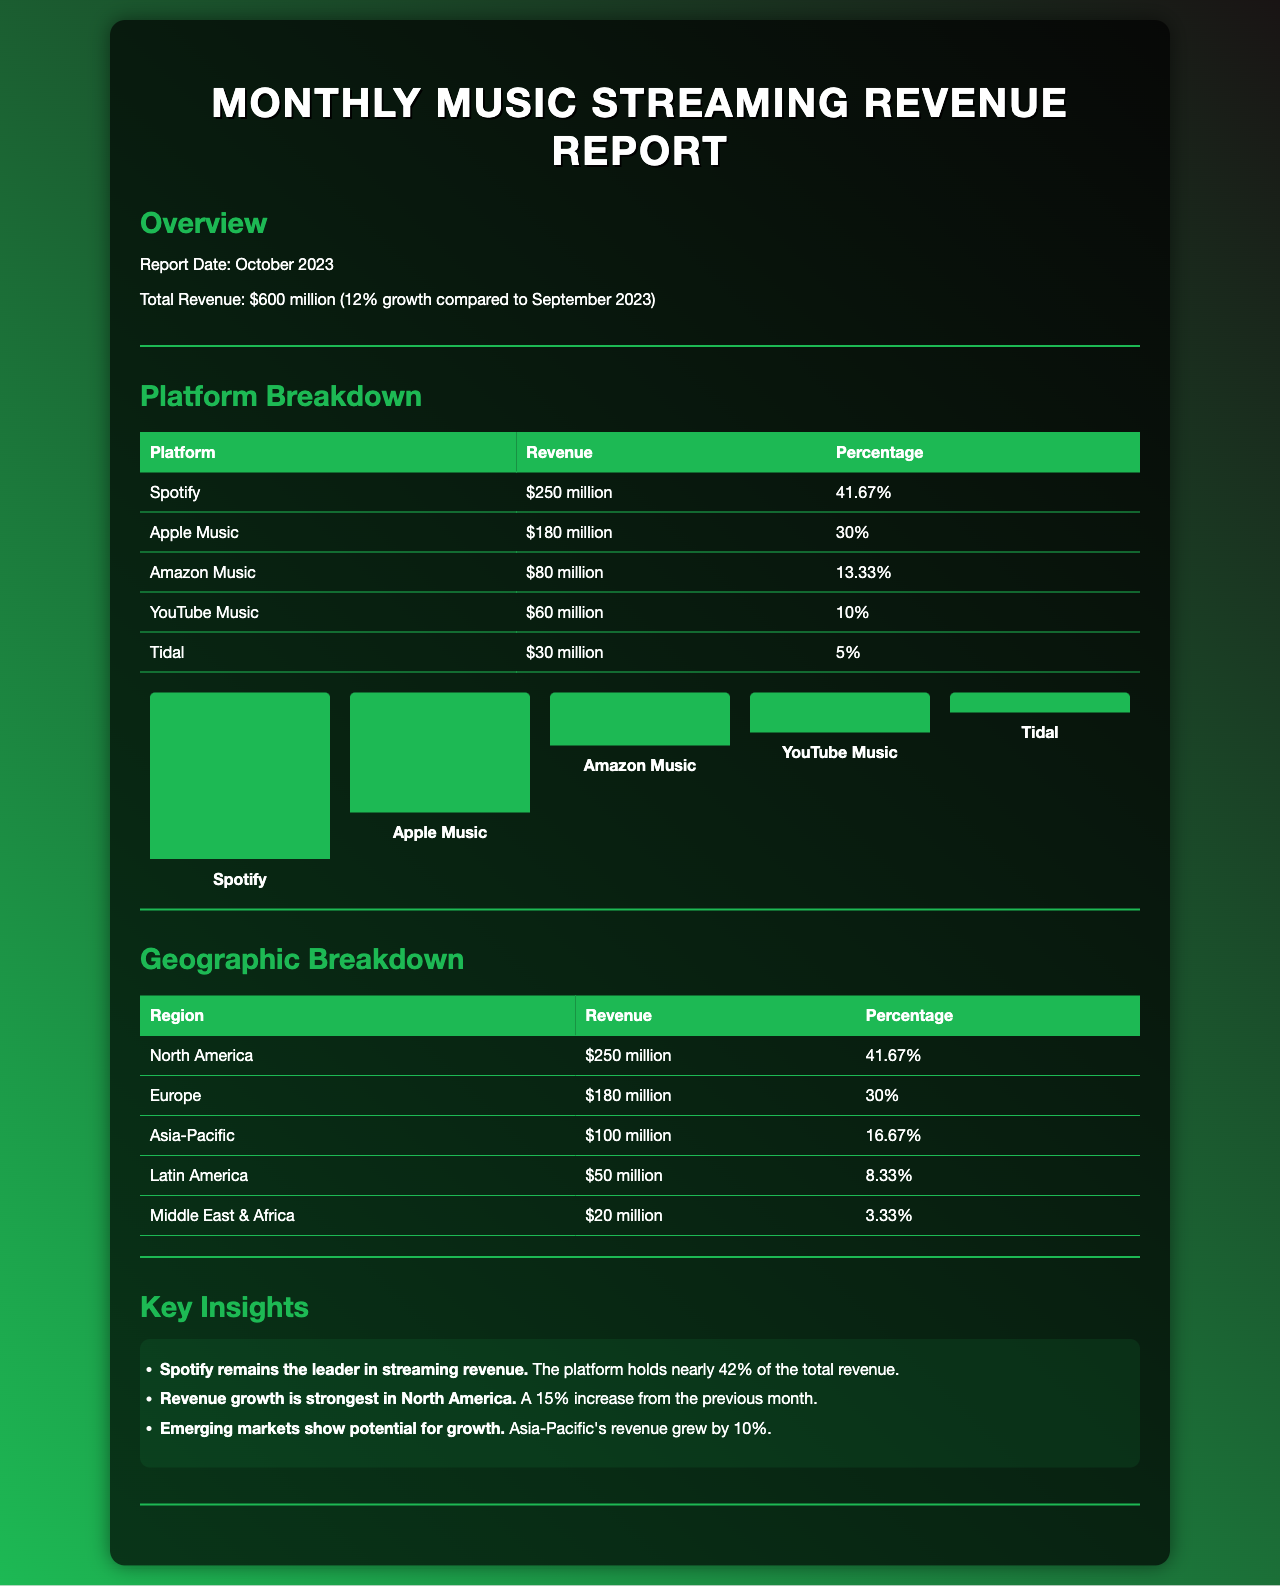what is the total revenue? The total revenue is stated in the overview section of the document as $600 million.
Answer: $600 million which platform has the highest revenue? The platform breakdown table shows that Spotify has the highest revenue, with $250 million.
Answer: Spotify what percentage of revenue does YouTube Music represent? The platform breakdown table indicates that YouTube Music contributes 10% of the total revenue.
Answer: 10% how much did revenue grow compared to September 2023? The overview section states that revenue growth is 12% compared to the previous month.
Answer: 12% which region has the lowest revenue? The geographic breakdown table shows that the Middle East & Africa has the lowest revenue, which is $20 million.
Answer: Middle East & Africa what was the revenue from Asia-Pacific? In the geographic breakdown section, Asia-Pacific's revenue is reported as $100 million.
Answer: $100 million which platform's revenue is $80 million? The platform breakdown indicates that Amazon Music has a revenue of $80 million.
Answer: Amazon Music what is the percentage of revenue from North America? The geographic breakdown states that North America constitutes 41.67% of the total revenue.
Answer: 41.67% which platform saw the second highest earnings? The platform breakdown shows that Apple Music is the second highest with $180 million.
Answer: Apple Music 